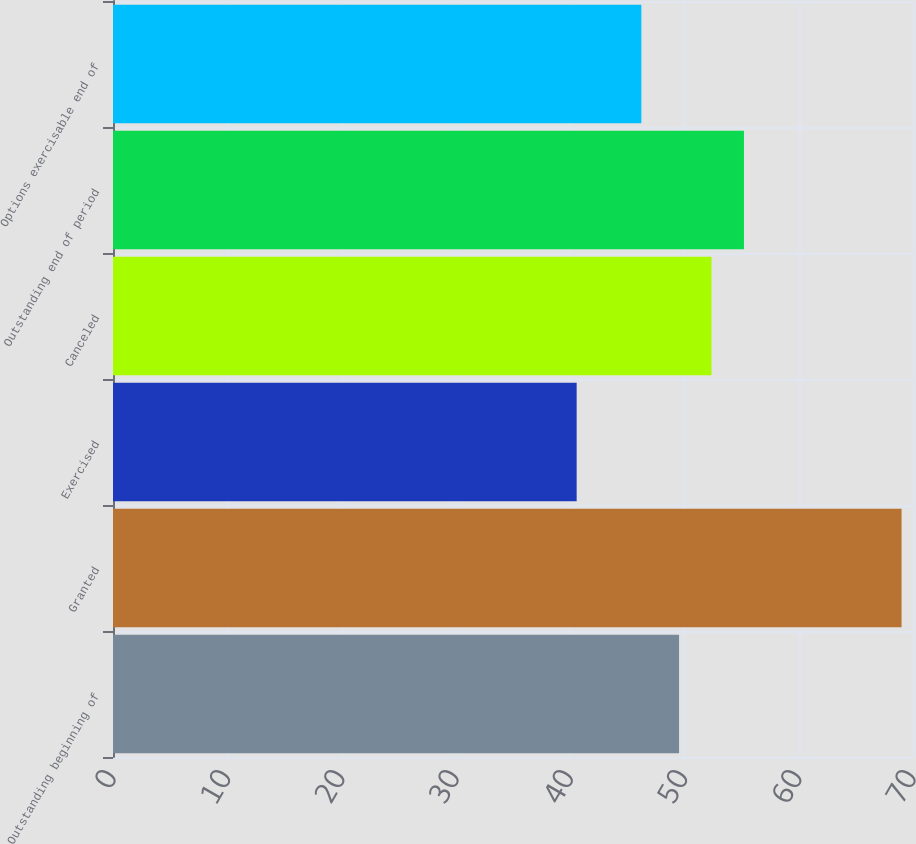Convert chart. <chart><loc_0><loc_0><loc_500><loc_500><bar_chart><fcel>Outstanding beginning of<fcel>Granted<fcel>Exercised<fcel>Canceled<fcel>Outstanding end of period<fcel>Options exercisable end of<nl><fcel>49.53<fcel>69<fcel>40.57<fcel>52.37<fcel>55.21<fcel>46.23<nl></chart> 